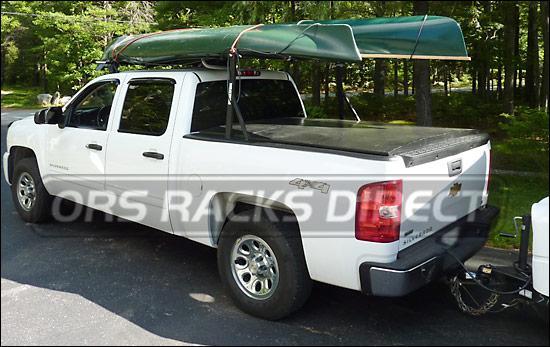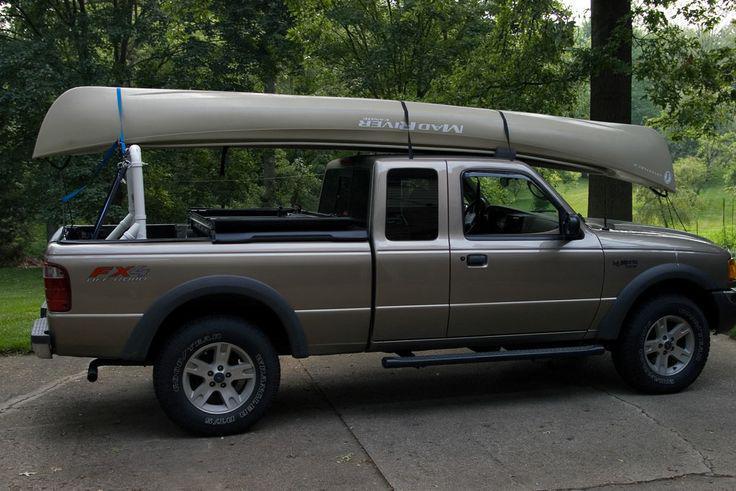The first image is the image on the left, the second image is the image on the right. Considering the images on both sides, is "A pickup carrying two different colored canoes is heading away from the camera, in one image." valid? Answer yes or no. No. 